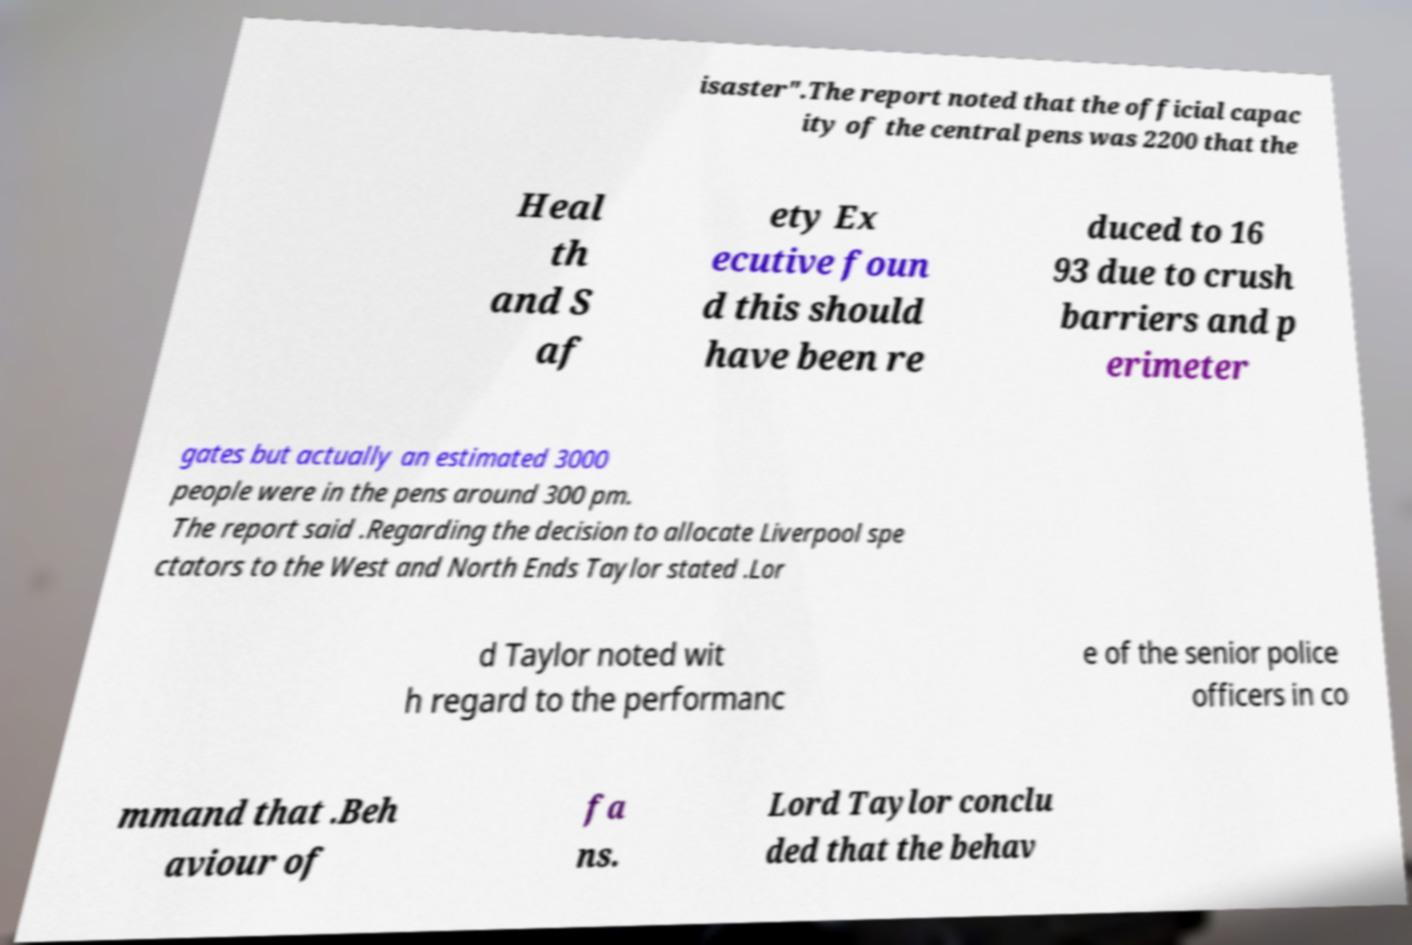What messages or text are displayed in this image? I need them in a readable, typed format. isaster".The report noted that the official capac ity of the central pens was 2200 that the Heal th and S af ety Ex ecutive foun d this should have been re duced to 16 93 due to crush barriers and p erimeter gates but actually an estimated 3000 people were in the pens around 300 pm. The report said .Regarding the decision to allocate Liverpool spe ctators to the West and North Ends Taylor stated .Lor d Taylor noted wit h regard to the performanc e of the senior police officers in co mmand that .Beh aviour of fa ns. Lord Taylor conclu ded that the behav 